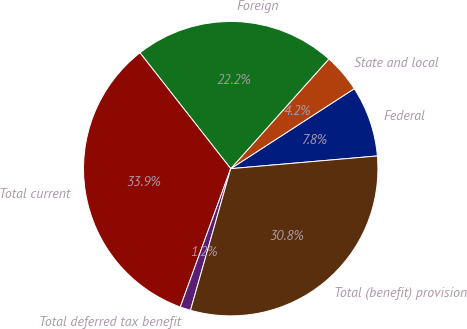Convert chart. <chart><loc_0><loc_0><loc_500><loc_500><pie_chart><fcel>Federal<fcel>State and local<fcel>Foreign<fcel>Total current<fcel>Total deferred tax benefit<fcel>Total (benefit) provision<nl><fcel>7.77%<fcel>4.24%<fcel>22.19%<fcel>33.86%<fcel>1.16%<fcel>30.78%<nl></chart> 